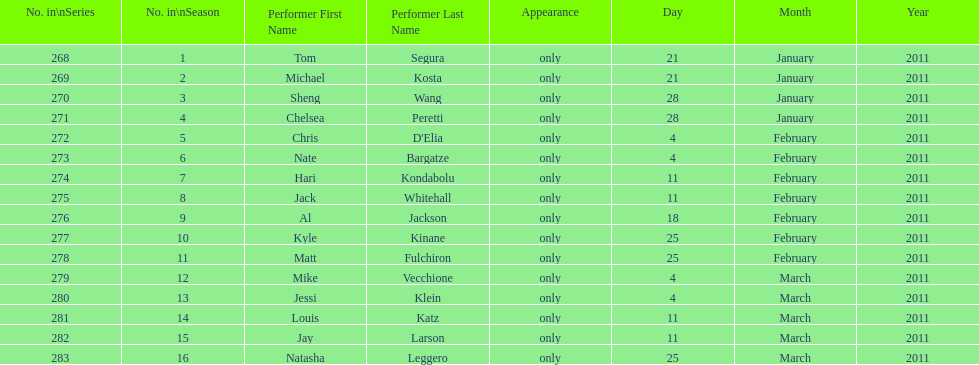How many episodes only had one performer? 16. 